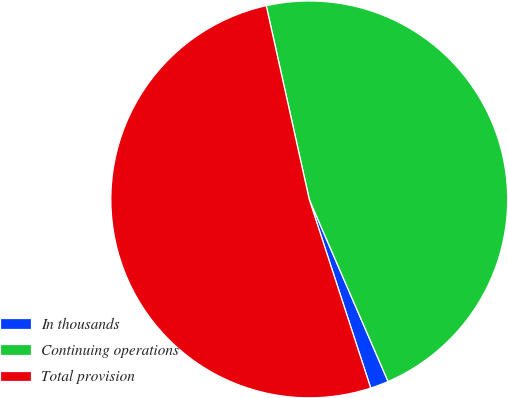Convert chart to OTSL. <chart><loc_0><loc_0><loc_500><loc_500><pie_chart><fcel>In thousands<fcel>Continuing operations<fcel>Total provision<nl><fcel>1.49%<fcel>46.97%<fcel>51.53%<nl></chart> 